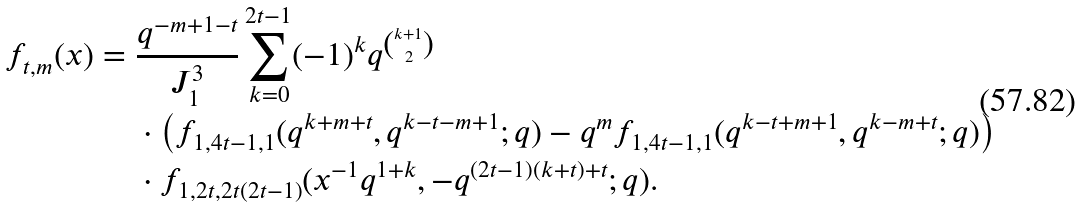<formula> <loc_0><loc_0><loc_500><loc_500>f _ { t , m } ( x ) & = \frac { q ^ { - m + 1 - t } } { J _ { 1 } ^ { 3 } } \sum _ { k = 0 } ^ { 2 t - 1 } ( - 1 ) ^ { k } q ^ { \binom { k + 1 } { 2 } } \\ & \quad \ \cdot \left ( f _ { 1 , 4 t - 1 , 1 } ( q ^ { k + m + t } , q ^ { k - t - m + 1 } ; q ) - q ^ { m } f _ { 1 , 4 t - 1 , 1 } ( q ^ { k - t + m + 1 } , q ^ { k - m + t } ; q ) \right ) \\ & \quad \ \cdot f _ { 1 , 2 t , 2 t ( 2 t - 1 ) } ( x ^ { - 1 } q ^ { 1 + k } , - q ^ { ( 2 t - 1 ) ( k + t ) + t } ; q ) .</formula> 